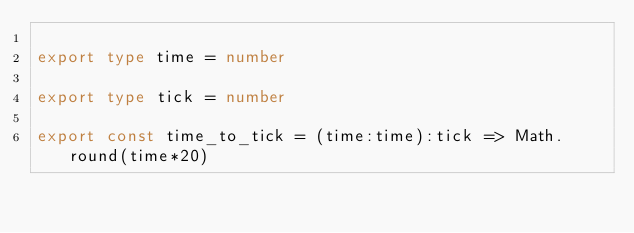<code> <loc_0><loc_0><loc_500><loc_500><_TypeScript_>
export type time = number

export type tick = number

export const time_to_tick = (time:time):tick => Math.round(time*20)
</code> 